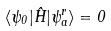Convert formula to latex. <formula><loc_0><loc_0><loc_500><loc_500>\langle \psi _ { 0 } | \hat { H } | \psi _ { a } ^ { r } \rangle = 0</formula> 